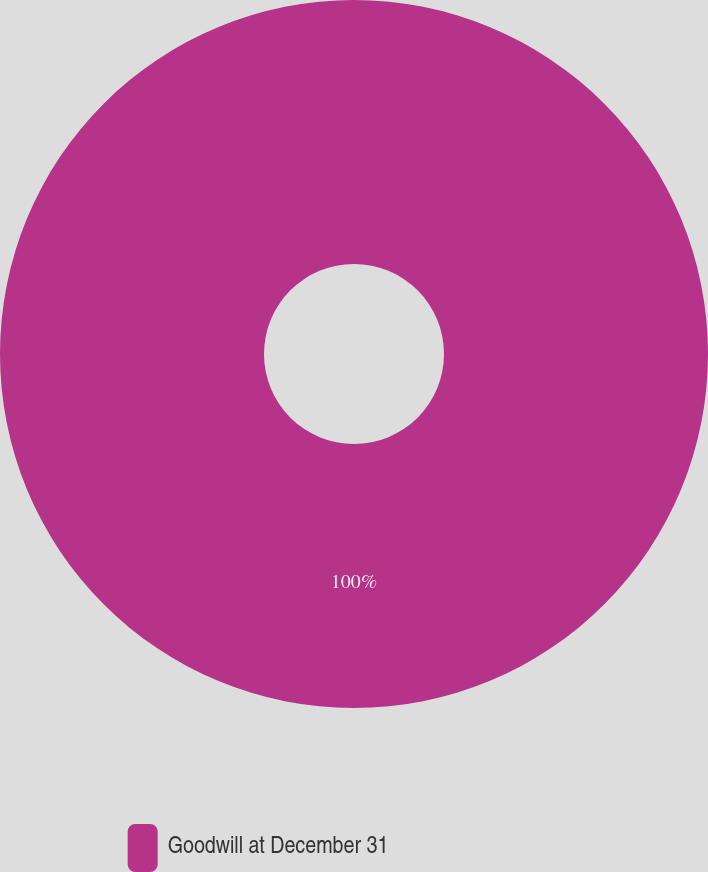<chart> <loc_0><loc_0><loc_500><loc_500><pie_chart><fcel>Goodwill at December 31<nl><fcel>100.0%<nl></chart> 